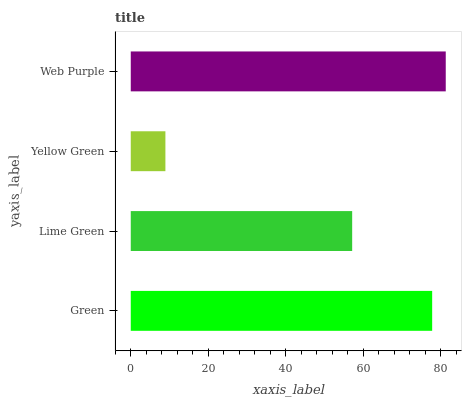Is Yellow Green the minimum?
Answer yes or no. Yes. Is Web Purple the maximum?
Answer yes or no. Yes. Is Lime Green the minimum?
Answer yes or no. No. Is Lime Green the maximum?
Answer yes or no. No. Is Green greater than Lime Green?
Answer yes or no. Yes. Is Lime Green less than Green?
Answer yes or no. Yes. Is Lime Green greater than Green?
Answer yes or no. No. Is Green less than Lime Green?
Answer yes or no. No. Is Green the high median?
Answer yes or no. Yes. Is Lime Green the low median?
Answer yes or no. Yes. Is Lime Green the high median?
Answer yes or no. No. Is Web Purple the low median?
Answer yes or no. No. 